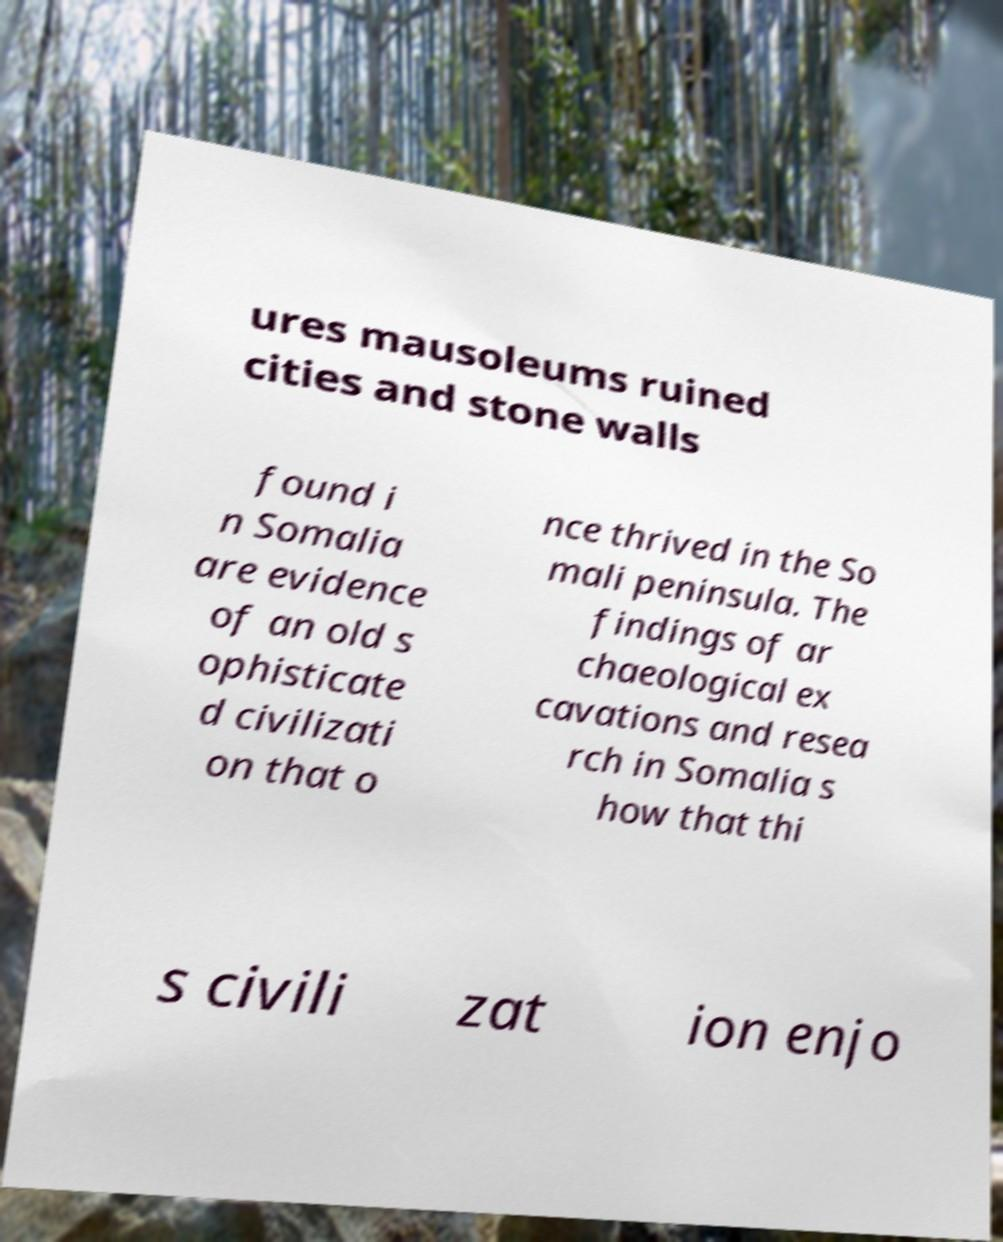There's text embedded in this image that I need extracted. Can you transcribe it verbatim? ures mausoleums ruined cities and stone walls found i n Somalia are evidence of an old s ophisticate d civilizati on that o nce thrived in the So mali peninsula. The findings of ar chaeological ex cavations and resea rch in Somalia s how that thi s civili zat ion enjo 